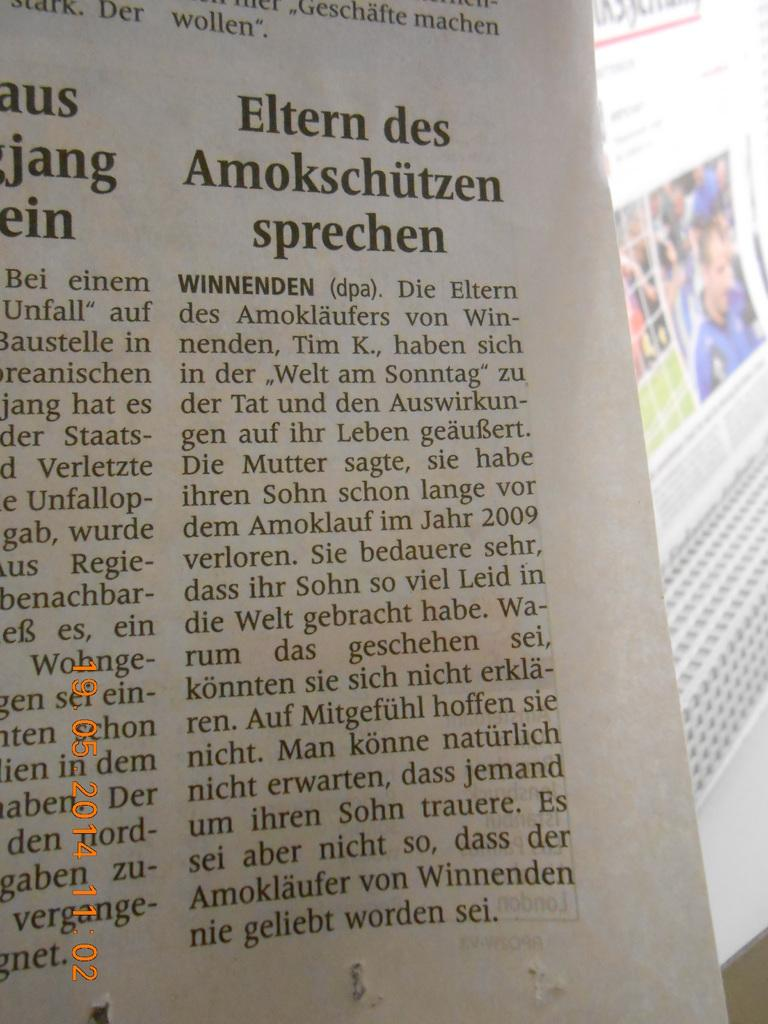<image>
Create a compact narrative representing the image presented. A newspaper headline reads "Eltern des Smokschutzen sprechen". 